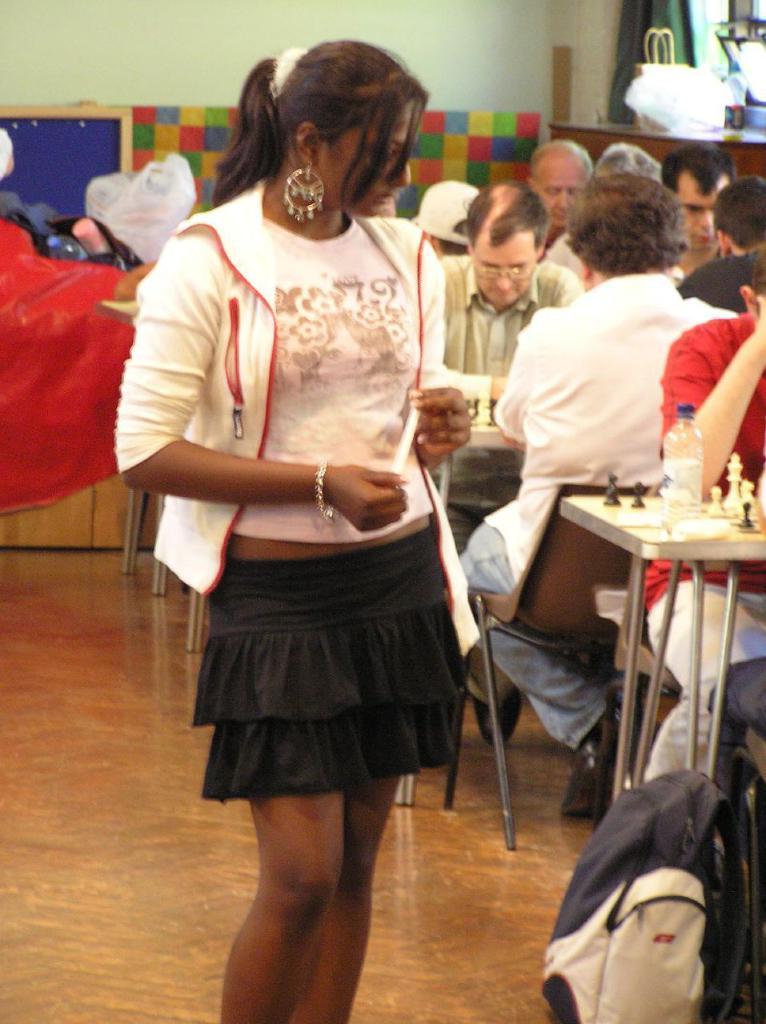Could you give a brief overview of what you see in this image? In this image we can see a girl standing on the left and she is holding an object in her hands. On the right side there are few persons sitting on the chairs at the tables and on the tables we can see chess boards, coins and a bottle, bag on the floor. In the background there are objects on the tables and platforms and we can see curtain, wall and other objects. 